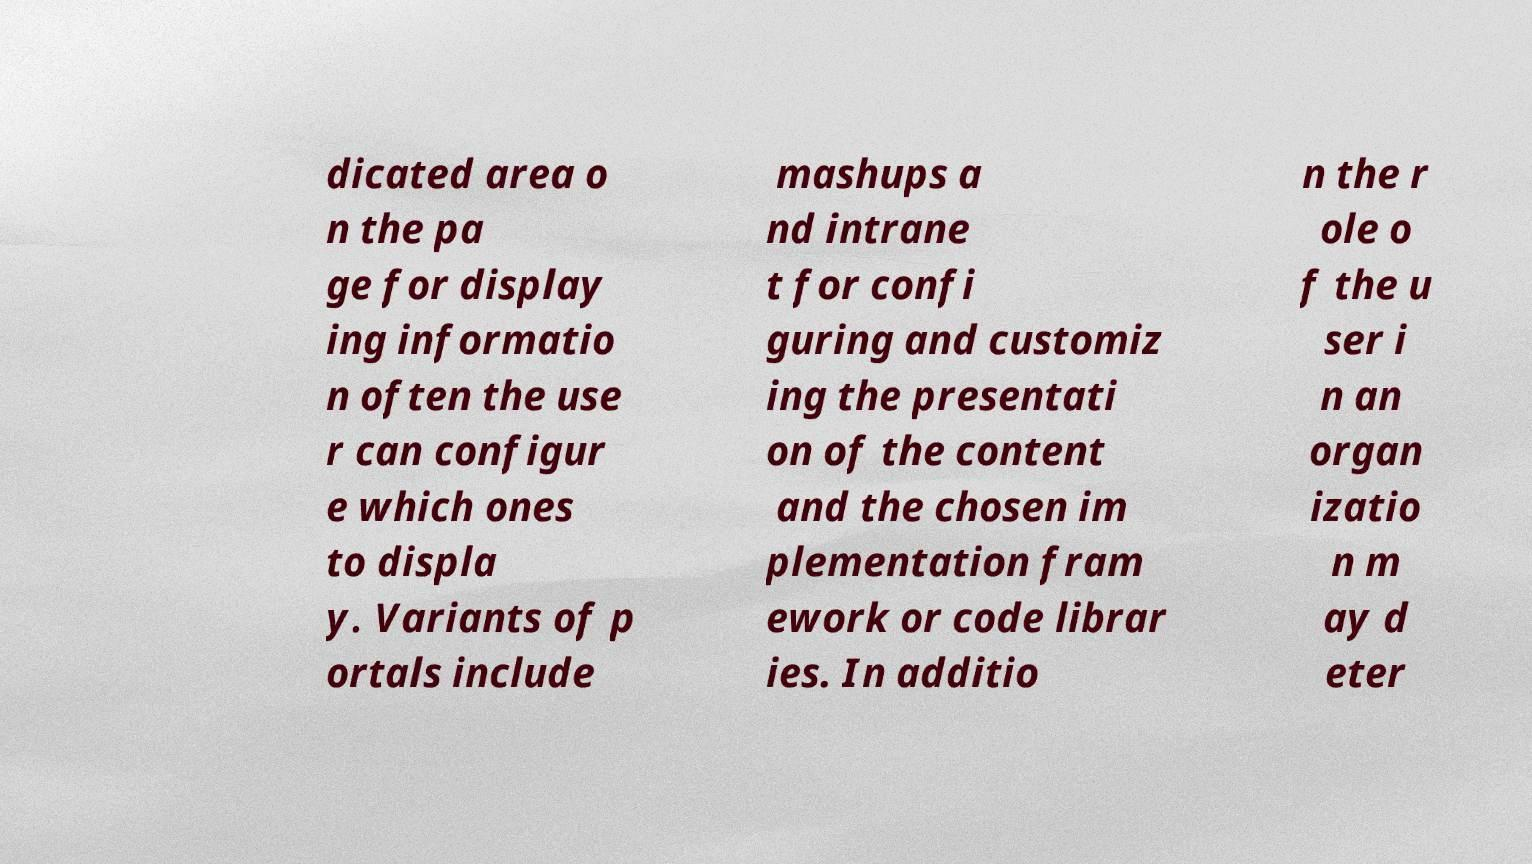What messages or text are displayed in this image? I need them in a readable, typed format. dicated area o n the pa ge for display ing informatio n often the use r can configur e which ones to displa y. Variants of p ortals include mashups a nd intrane t for confi guring and customiz ing the presentati on of the content and the chosen im plementation fram ework or code librar ies. In additio n the r ole o f the u ser i n an organ izatio n m ay d eter 